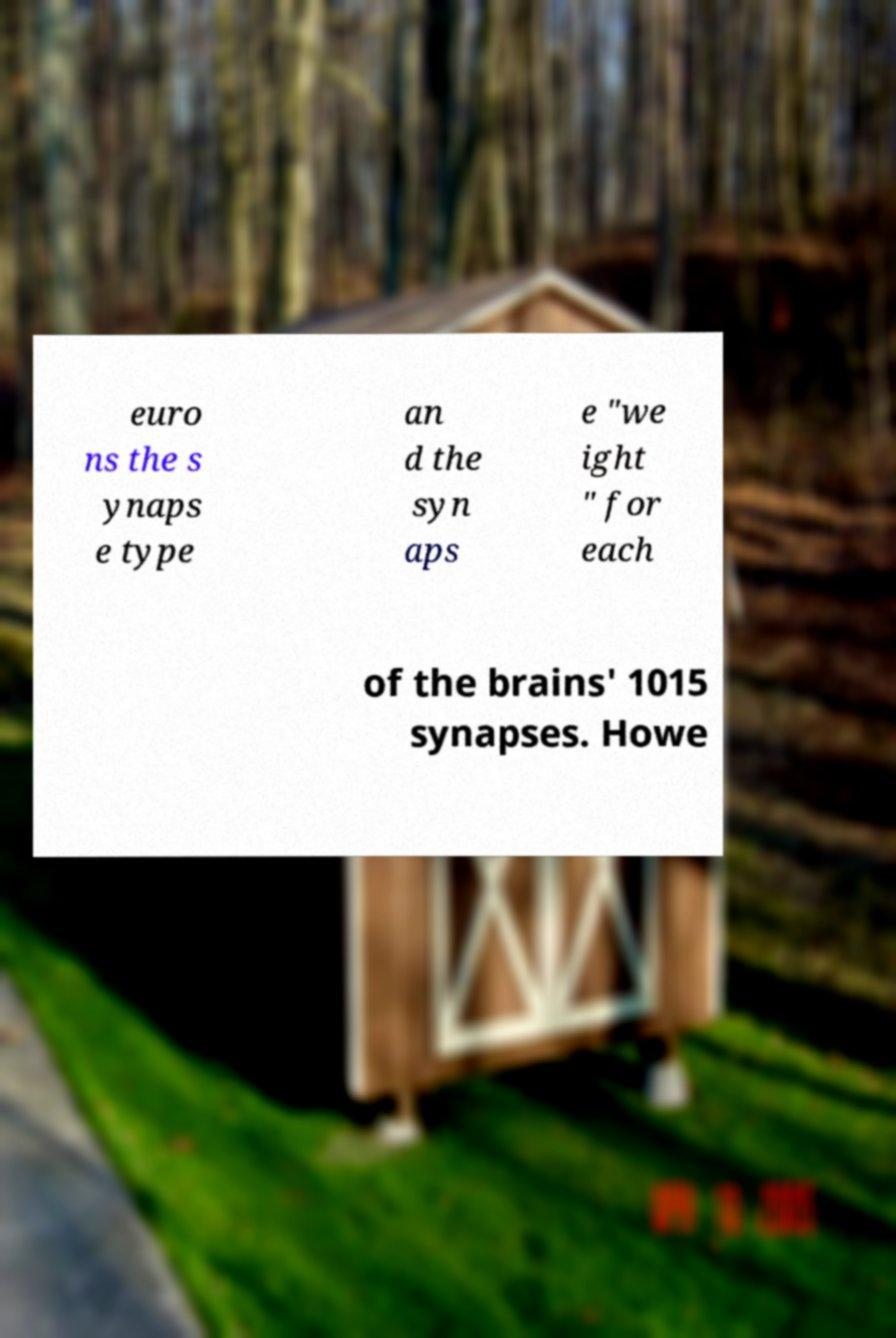For documentation purposes, I need the text within this image transcribed. Could you provide that? euro ns the s ynaps e type an d the syn aps e "we ight " for each of the brains' 1015 synapses. Howe 